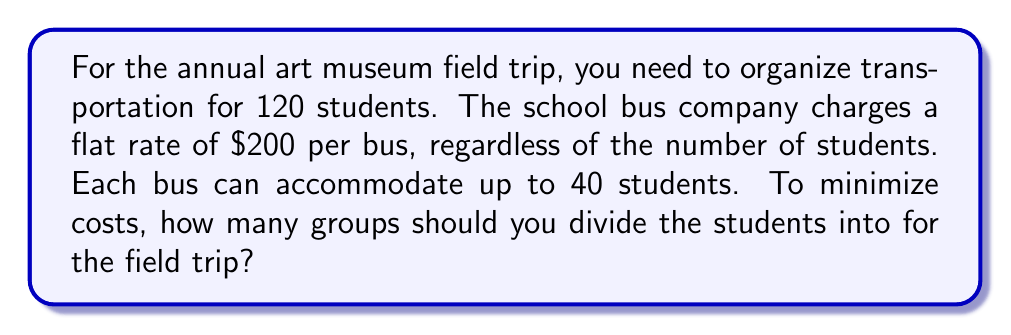Give your solution to this math problem. To solve this problem, we need to find the optimal number of groups that minimizes the total cost while ensuring all students can be transported. Let's approach this step-by-step:

1. Given information:
   - Total number of students: 120
   - Bus capacity: 40 students
   - Cost per bus: $200

2. Let's define a variable:
   Let $x$ be the number of groups (which is also the number of buses needed)

3. Calculate the number of students per group:
   Students per group = Total students ÷ Number of groups
   $\frac{120}{x}$

4. Constraints:
   - The number of students per group must not exceed the bus capacity:
     $\frac{120}{x} \leq 40$
   - The number of groups must be a whole number

5. Total cost function:
   Cost = Number of groups × Cost per bus
   $C(x) = 200x$

6. To find the minimum cost, we need to use the smallest number of buses that can accommodate all students:
   $\frac{120}{x} \leq 40$
   $120 \leq 40x$
   $3 \leq x$

7. Since $x$ must be a whole number, the smallest value that satisfies this inequality is 3.

8. Verify:
   With 3 groups, each group would have 40 students (120 ÷ 3 = 40), which exactly matches the bus capacity.

9. Calculate the total cost:
   $C(3) = 200 \times 3 = 600$

Therefore, the optimal number of groups is 3, which minimizes the transportation cost at $600.
Answer: The optimal number of groups is 3. 